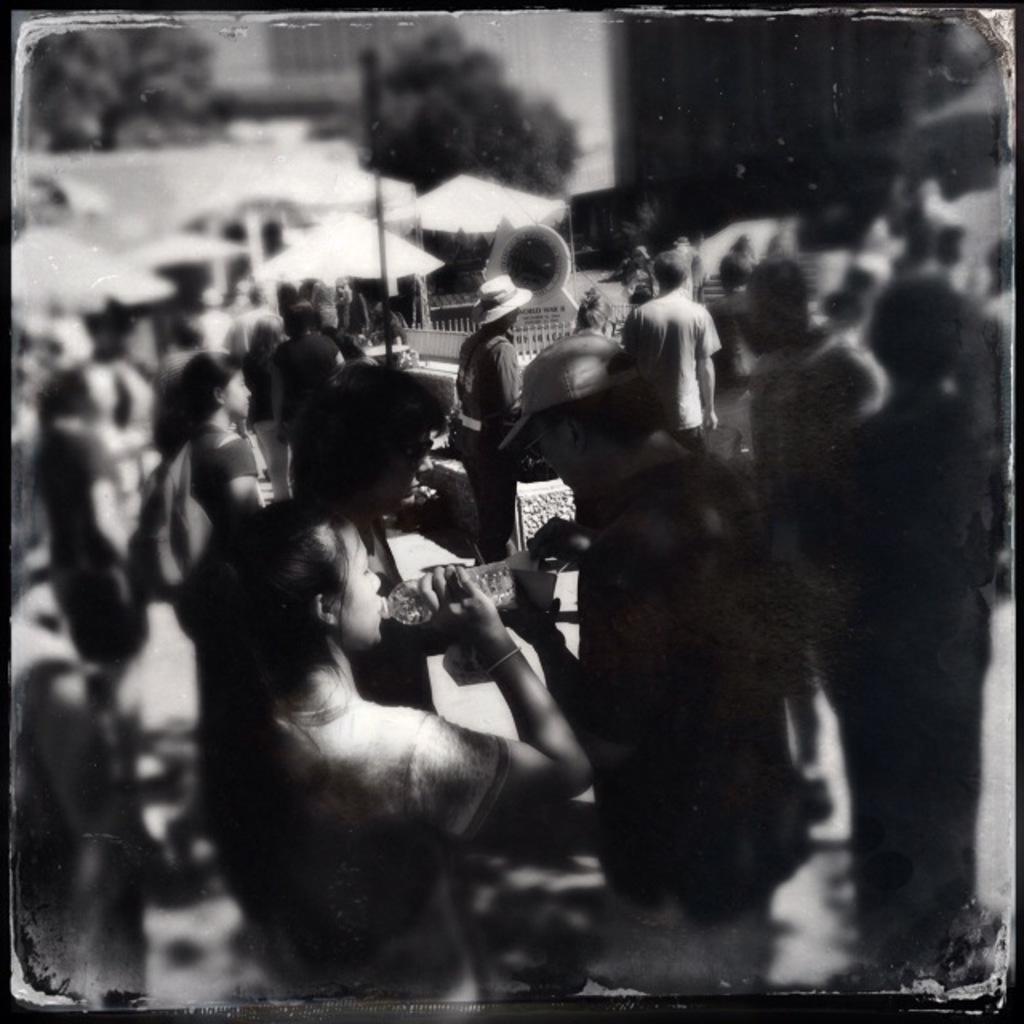Can you describe this image briefly? In the picture we can see black and white photography with many people are standing and talking to each other and in the background, we can see some trees which are not clearly visible. 